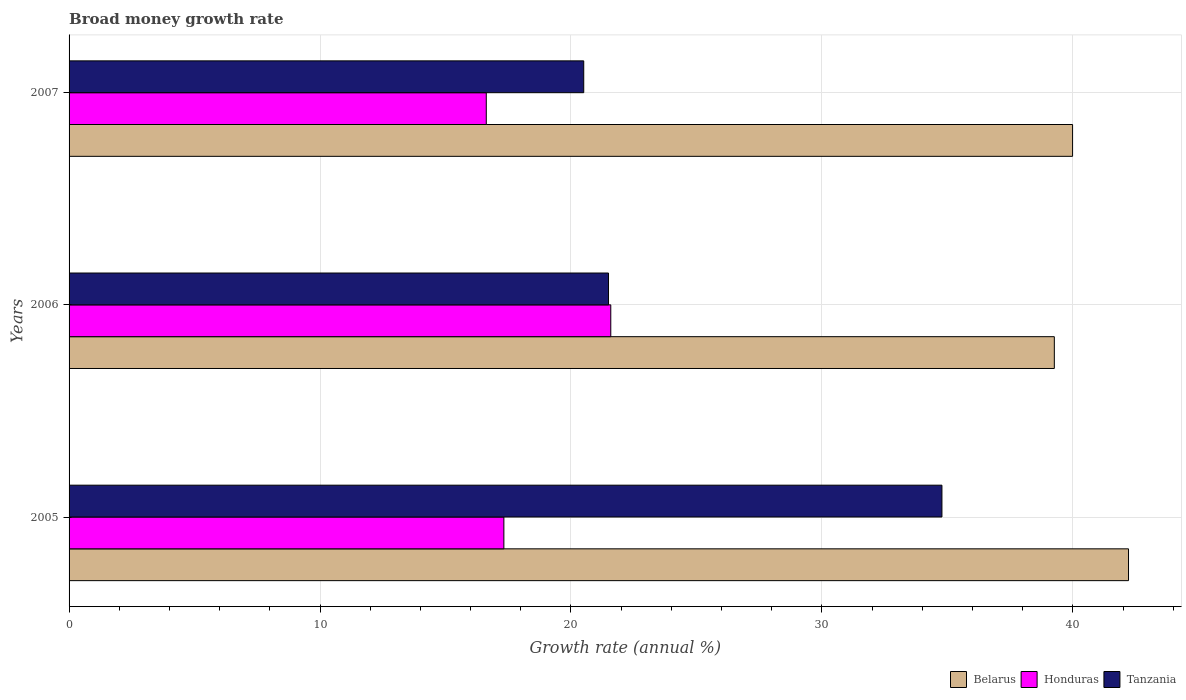How many different coloured bars are there?
Your answer should be very brief. 3. How many groups of bars are there?
Keep it short and to the point. 3. Are the number of bars per tick equal to the number of legend labels?
Make the answer very short. Yes. Are the number of bars on each tick of the Y-axis equal?
Ensure brevity in your answer.  Yes. How many bars are there on the 2nd tick from the top?
Give a very brief answer. 3. How many bars are there on the 1st tick from the bottom?
Offer a terse response. 3. What is the label of the 2nd group of bars from the top?
Your answer should be very brief. 2006. In how many cases, is the number of bars for a given year not equal to the number of legend labels?
Offer a terse response. 0. What is the growth rate in Tanzania in 2006?
Your answer should be very brief. 21.5. Across all years, what is the maximum growth rate in Tanzania?
Provide a succinct answer. 34.78. Across all years, what is the minimum growth rate in Tanzania?
Provide a short and direct response. 20.51. In which year was the growth rate in Tanzania maximum?
Ensure brevity in your answer.  2005. In which year was the growth rate in Tanzania minimum?
Provide a short and direct response. 2007. What is the total growth rate in Tanzania in the graph?
Your answer should be very brief. 76.79. What is the difference between the growth rate in Tanzania in 2006 and that in 2007?
Your response must be concise. 0.99. What is the difference between the growth rate in Belarus in 2005 and the growth rate in Tanzania in 2007?
Your answer should be very brief. 21.71. What is the average growth rate in Belarus per year?
Provide a succinct answer. 40.49. In the year 2005, what is the difference between the growth rate in Honduras and growth rate in Tanzania?
Your answer should be compact. -17.46. In how many years, is the growth rate in Tanzania greater than 38 %?
Offer a very short reply. 0. What is the ratio of the growth rate in Tanzania in 2005 to that in 2007?
Ensure brevity in your answer.  1.7. Is the difference between the growth rate in Honduras in 2006 and 2007 greater than the difference between the growth rate in Tanzania in 2006 and 2007?
Your answer should be compact. Yes. What is the difference between the highest and the second highest growth rate in Tanzania?
Offer a very short reply. 13.29. What is the difference between the highest and the lowest growth rate in Honduras?
Make the answer very short. 4.96. In how many years, is the growth rate in Tanzania greater than the average growth rate in Tanzania taken over all years?
Provide a succinct answer. 1. Is the sum of the growth rate in Honduras in 2005 and 2007 greater than the maximum growth rate in Belarus across all years?
Make the answer very short. No. What does the 3rd bar from the top in 2007 represents?
Offer a very short reply. Belarus. What does the 1st bar from the bottom in 2006 represents?
Offer a very short reply. Belarus. Is it the case that in every year, the sum of the growth rate in Belarus and growth rate in Honduras is greater than the growth rate in Tanzania?
Your response must be concise. Yes. How many bars are there?
Offer a terse response. 9. How many years are there in the graph?
Provide a short and direct response. 3. Does the graph contain any zero values?
Keep it short and to the point. No. Does the graph contain grids?
Offer a very short reply. Yes. How many legend labels are there?
Keep it short and to the point. 3. What is the title of the graph?
Offer a terse response. Broad money growth rate. Does "Austria" appear as one of the legend labels in the graph?
Provide a short and direct response. No. What is the label or title of the X-axis?
Your answer should be very brief. Growth rate (annual %). What is the Growth rate (annual %) of Belarus in 2005?
Ensure brevity in your answer.  42.22. What is the Growth rate (annual %) of Honduras in 2005?
Your response must be concise. 17.33. What is the Growth rate (annual %) in Tanzania in 2005?
Give a very brief answer. 34.78. What is the Growth rate (annual %) in Belarus in 2006?
Your answer should be very brief. 39.26. What is the Growth rate (annual %) in Honduras in 2006?
Offer a terse response. 21.59. What is the Growth rate (annual %) in Tanzania in 2006?
Ensure brevity in your answer.  21.5. What is the Growth rate (annual %) in Belarus in 2007?
Provide a succinct answer. 39.99. What is the Growth rate (annual %) of Honduras in 2007?
Offer a very short reply. 16.62. What is the Growth rate (annual %) of Tanzania in 2007?
Offer a very short reply. 20.51. Across all years, what is the maximum Growth rate (annual %) in Belarus?
Give a very brief answer. 42.22. Across all years, what is the maximum Growth rate (annual %) of Honduras?
Your response must be concise. 21.59. Across all years, what is the maximum Growth rate (annual %) in Tanzania?
Ensure brevity in your answer.  34.78. Across all years, what is the minimum Growth rate (annual %) of Belarus?
Give a very brief answer. 39.26. Across all years, what is the minimum Growth rate (annual %) of Honduras?
Your answer should be compact. 16.62. Across all years, what is the minimum Growth rate (annual %) of Tanzania?
Keep it short and to the point. 20.51. What is the total Growth rate (annual %) in Belarus in the graph?
Offer a very short reply. 121.46. What is the total Growth rate (annual %) of Honduras in the graph?
Your answer should be very brief. 55.54. What is the total Growth rate (annual %) of Tanzania in the graph?
Offer a very short reply. 76.79. What is the difference between the Growth rate (annual %) of Belarus in 2005 and that in 2006?
Offer a terse response. 2.96. What is the difference between the Growth rate (annual %) of Honduras in 2005 and that in 2006?
Make the answer very short. -4.26. What is the difference between the Growth rate (annual %) of Tanzania in 2005 and that in 2006?
Ensure brevity in your answer.  13.29. What is the difference between the Growth rate (annual %) of Belarus in 2005 and that in 2007?
Provide a succinct answer. 2.23. What is the difference between the Growth rate (annual %) of Honduras in 2005 and that in 2007?
Provide a succinct answer. 0.7. What is the difference between the Growth rate (annual %) of Tanzania in 2005 and that in 2007?
Offer a very short reply. 14.27. What is the difference between the Growth rate (annual %) of Belarus in 2006 and that in 2007?
Your response must be concise. -0.73. What is the difference between the Growth rate (annual %) of Honduras in 2006 and that in 2007?
Provide a short and direct response. 4.96. What is the difference between the Growth rate (annual %) in Belarus in 2005 and the Growth rate (annual %) in Honduras in 2006?
Your answer should be compact. 20.63. What is the difference between the Growth rate (annual %) of Belarus in 2005 and the Growth rate (annual %) of Tanzania in 2006?
Offer a terse response. 20.72. What is the difference between the Growth rate (annual %) of Honduras in 2005 and the Growth rate (annual %) of Tanzania in 2006?
Ensure brevity in your answer.  -4.17. What is the difference between the Growth rate (annual %) of Belarus in 2005 and the Growth rate (annual %) of Honduras in 2007?
Give a very brief answer. 25.59. What is the difference between the Growth rate (annual %) of Belarus in 2005 and the Growth rate (annual %) of Tanzania in 2007?
Give a very brief answer. 21.71. What is the difference between the Growth rate (annual %) of Honduras in 2005 and the Growth rate (annual %) of Tanzania in 2007?
Provide a short and direct response. -3.18. What is the difference between the Growth rate (annual %) in Belarus in 2006 and the Growth rate (annual %) in Honduras in 2007?
Your answer should be very brief. 22.64. What is the difference between the Growth rate (annual %) in Belarus in 2006 and the Growth rate (annual %) in Tanzania in 2007?
Your response must be concise. 18.75. What is the difference between the Growth rate (annual %) in Honduras in 2006 and the Growth rate (annual %) in Tanzania in 2007?
Keep it short and to the point. 1.08. What is the average Growth rate (annual %) of Belarus per year?
Offer a very short reply. 40.49. What is the average Growth rate (annual %) of Honduras per year?
Provide a succinct answer. 18.51. What is the average Growth rate (annual %) of Tanzania per year?
Keep it short and to the point. 25.6. In the year 2005, what is the difference between the Growth rate (annual %) in Belarus and Growth rate (annual %) in Honduras?
Keep it short and to the point. 24.89. In the year 2005, what is the difference between the Growth rate (annual %) in Belarus and Growth rate (annual %) in Tanzania?
Make the answer very short. 7.43. In the year 2005, what is the difference between the Growth rate (annual %) in Honduras and Growth rate (annual %) in Tanzania?
Your response must be concise. -17.46. In the year 2006, what is the difference between the Growth rate (annual %) in Belarus and Growth rate (annual %) in Honduras?
Offer a very short reply. 17.67. In the year 2006, what is the difference between the Growth rate (annual %) in Belarus and Growth rate (annual %) in Tanzania?
Provide a short and direct response. 17.76. In the year 2006, what is the difference between the Growth rate (annual %) of Honduras and Growth rate (annual %) of Tanzania?
Provide a succinct answer. 0.09. In the year 2007, what is the difference between the Growth rate (annual %) of Belarus and Growth rate (annual %) of Honduras?
Your answer should be very brief. 23.36. In the year 2007, what is the difference between the Growth rate (annual %) in Belarus and Growth rate (annual %) in Tanzania?
Make the answer very short. 19.48. In the year 2007, what is the difference between the Growth rate (annual %) of Honduras and Growth rate (annual %) of Tanzania?
Give a very brief answer. -3.88. What is the ratio of the Growth rate (annual %) of Belarus in 2005 to that in 2006?
Provide a short and direct response. 1.08. What is the ratio of the Growth rate (annual %) of Honduras in 2005 to that in 2006?
Offer a very short reply. 0.8. What is the ratio of the Growth rate (annual %) of Tanzania in 2005 to that in 2006?
Your answer should be compact. 1.62. What is the ratio of the Growth rate (annual %) of Belarus in 2005 to that in 2007?
Ensure brevity in your answer.  1.06. What is the ratio of the Growth rate (annual %) of Honduras in 2005 to that in 2007?
Give a very brief answer. 1.04. What is the ratio of the Growth rate (annual %) of Tanzania in 2005 to that in 2007?
Ensure brevity in your answer.  1.7. What is the ratio of the Growth rate (annual %) in Belarus in 2006 to that in 2007?
Your response must be concise. 0.98. What is the ratio of the Growth rate (annual %) of Honduras in 2006 to that in 2007?
Your response must be concise. 1.3. What is the ratio of the Growth rate (annual %) of Tanzania in 2006 to that in 2007?
Your response must be concise. 1.05. What is the difference between the highest and the second highest Growth rate (annual %) in Belarus?
Make the answer very short. 2.23. What is the difference between the highest and the second highest Growth rate (annual %) of Honduras?
Your answer should be very brief. 4.26. What is the difference between the highest and the second highest Growth rate (annual %) in Tanzania?
Offer a terse response. 13.29. What is the difference between the highest and the lowest Growth rate (annual %) in Belarus?
Offer a very short reply. 2.96. What is the difference between the highest and the lowest Growth rate (annual %) in Honduras?
Provide a short and direct response. 4.96. What is the difference between the highest and the lowest Growth rate (annual %) of Tanzania?
Your answer should be very brief. 14.27. 